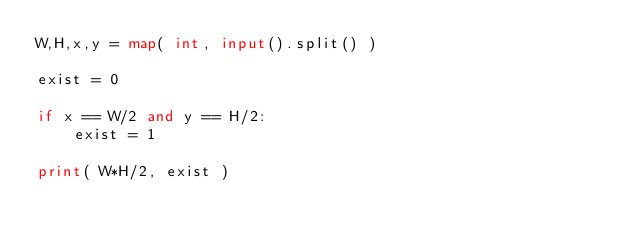<code> <loc_0><loc_0><loc_500><loc_500><_Python_>W,H,x,y = map( int, input().split() )

exist = 0

if x == W/2 and y == H/2:
    exist = 1

print( W*H/2, exist )</code> 